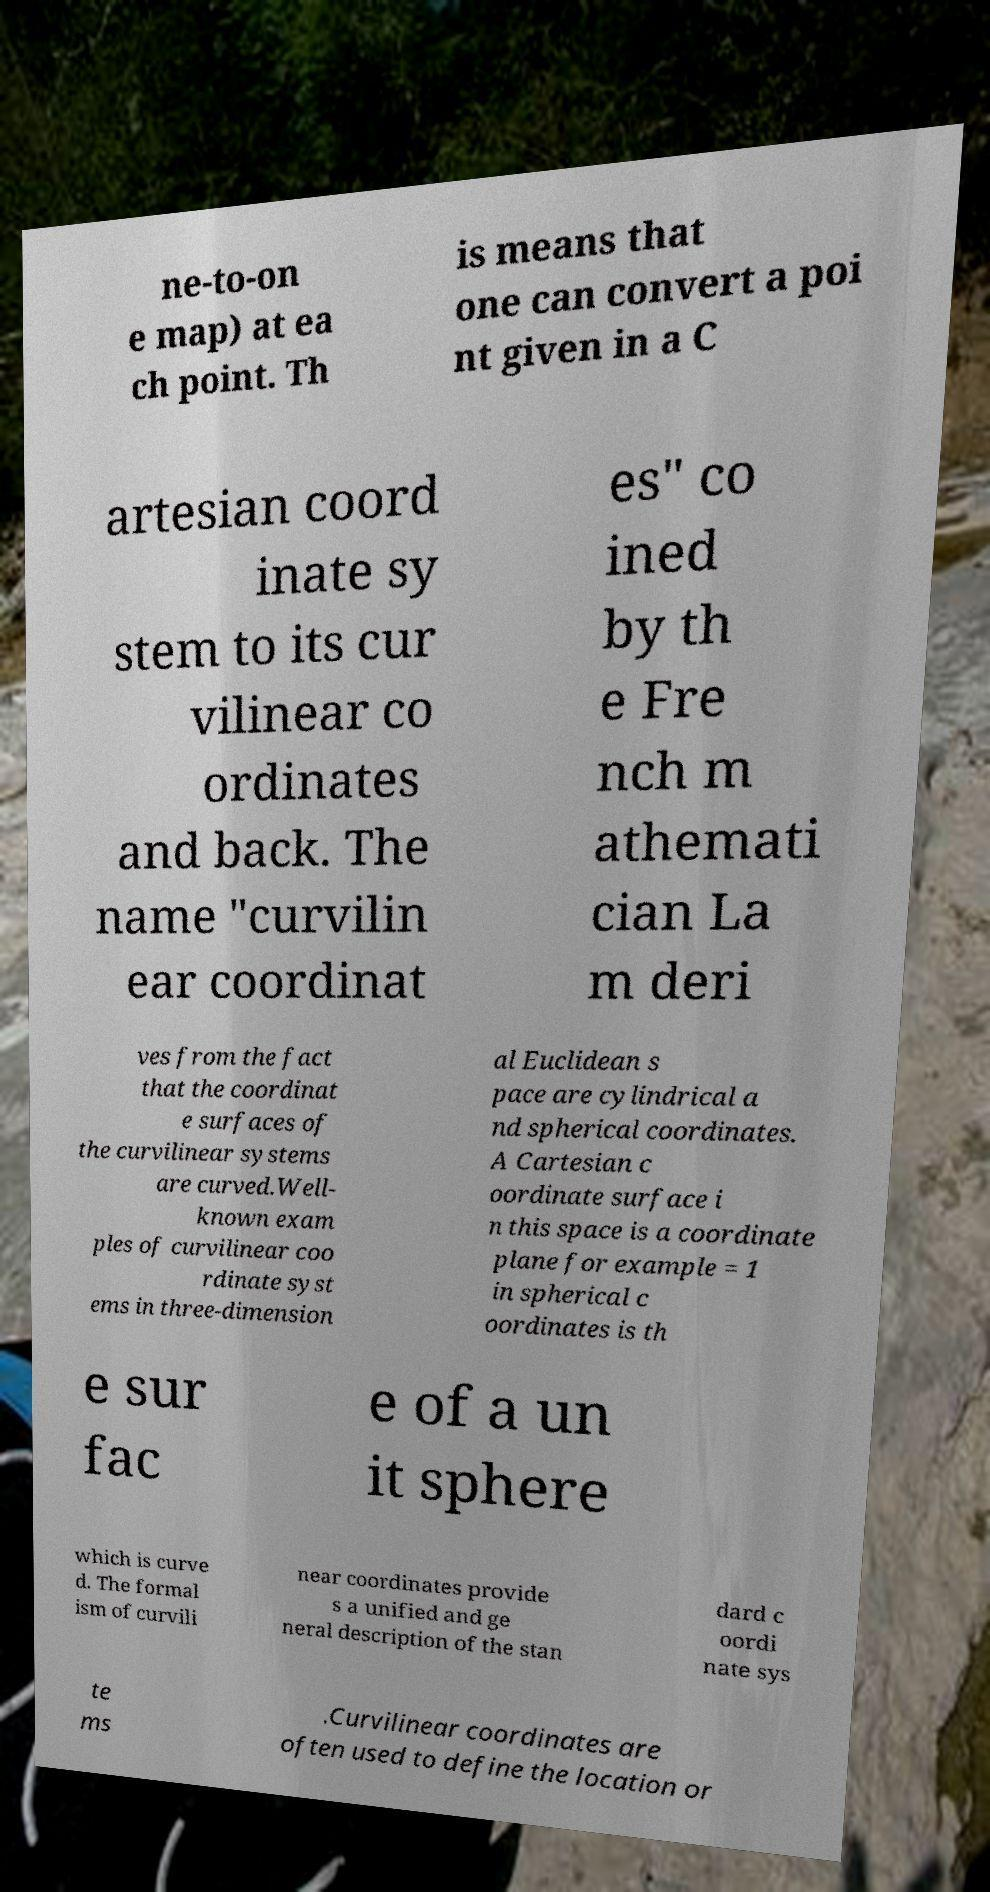Please identify and transcribe the text found in this image. ne-to-on e map) at ea ch point. Th is means that one can convert a poi nt given in a C artesian coord inate sy stem to its cur vilinear co ordinates and back. The name "curvilin ear coordinat es" co ined by th e Fre nch m athemati cian La m deri ves from the fact that the coordinat e surfaces of the curvilinear systems are curved.Well- known exam ples of curvilinear coo rdinate syst ems in three-dimension al Euclidean s pace are cylindrical a nd spherical coordinates. A Cartesian c oordinate surface i n this space is a coordinate plane for example = 1 in spherical c oordinates is th e sur fac e of a un it sphere which is curve d. The formal ism of curvili near coordinates provide s a unified and ge neral description of the stan dard c oordi nate sys te ms .Curvilinear coordinates are often used to define the location or 